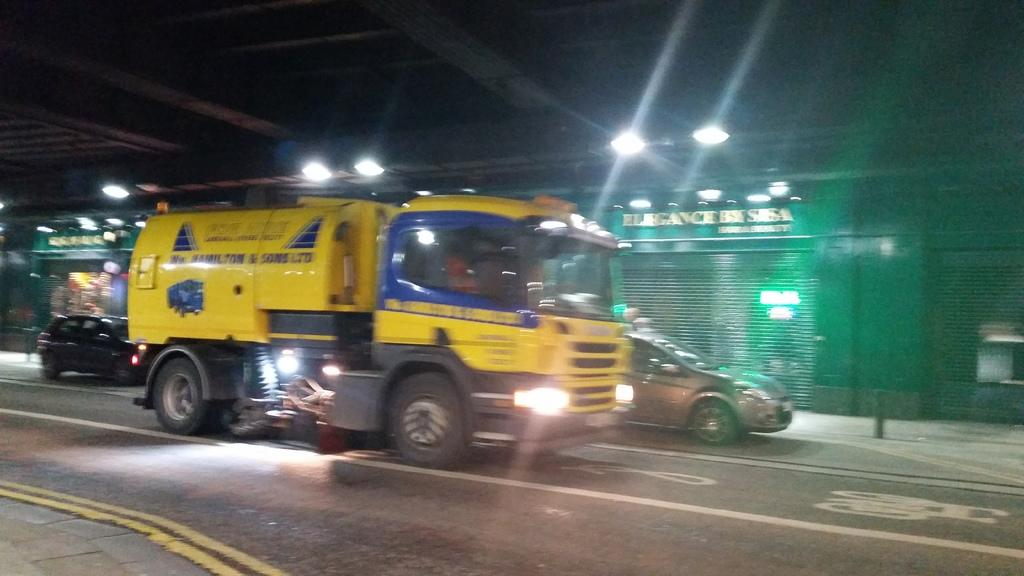What can be seen moving on the road in the image? There are vehicles on the road in the image. What is present on the roof in the image? There are light arrangements on the roof in the image. What type of window covering is visible in the image? Rolling shutters are visible in the image. How much does the caption on the image cost in dimes? There is no caption present in the image, so it cannot be priced in dimes. 